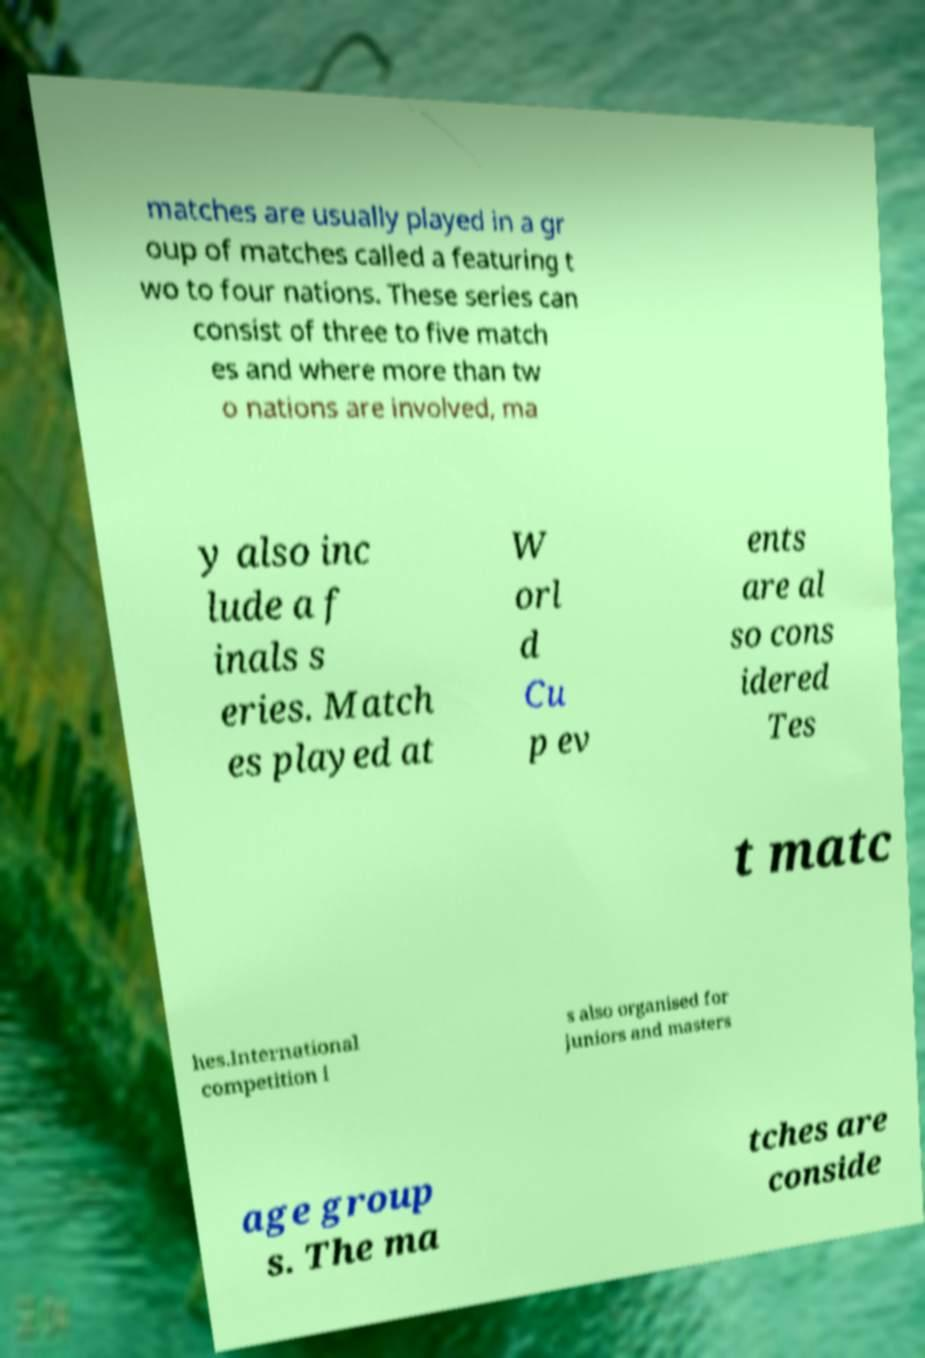Please identify and transcribe the text found in this image. matches are usually played in a gr oup of matches called a featuring t wo to four nations. These series can consist of three to five match es and where more than tw o nations are involved, ma y also inc lude a f inals s eries. Match es played at W orl d Cu p ev ents are al so cons idered Tes t matc hes.International competition i s also organised for juniors and masters age group s. The ma tches are conside 